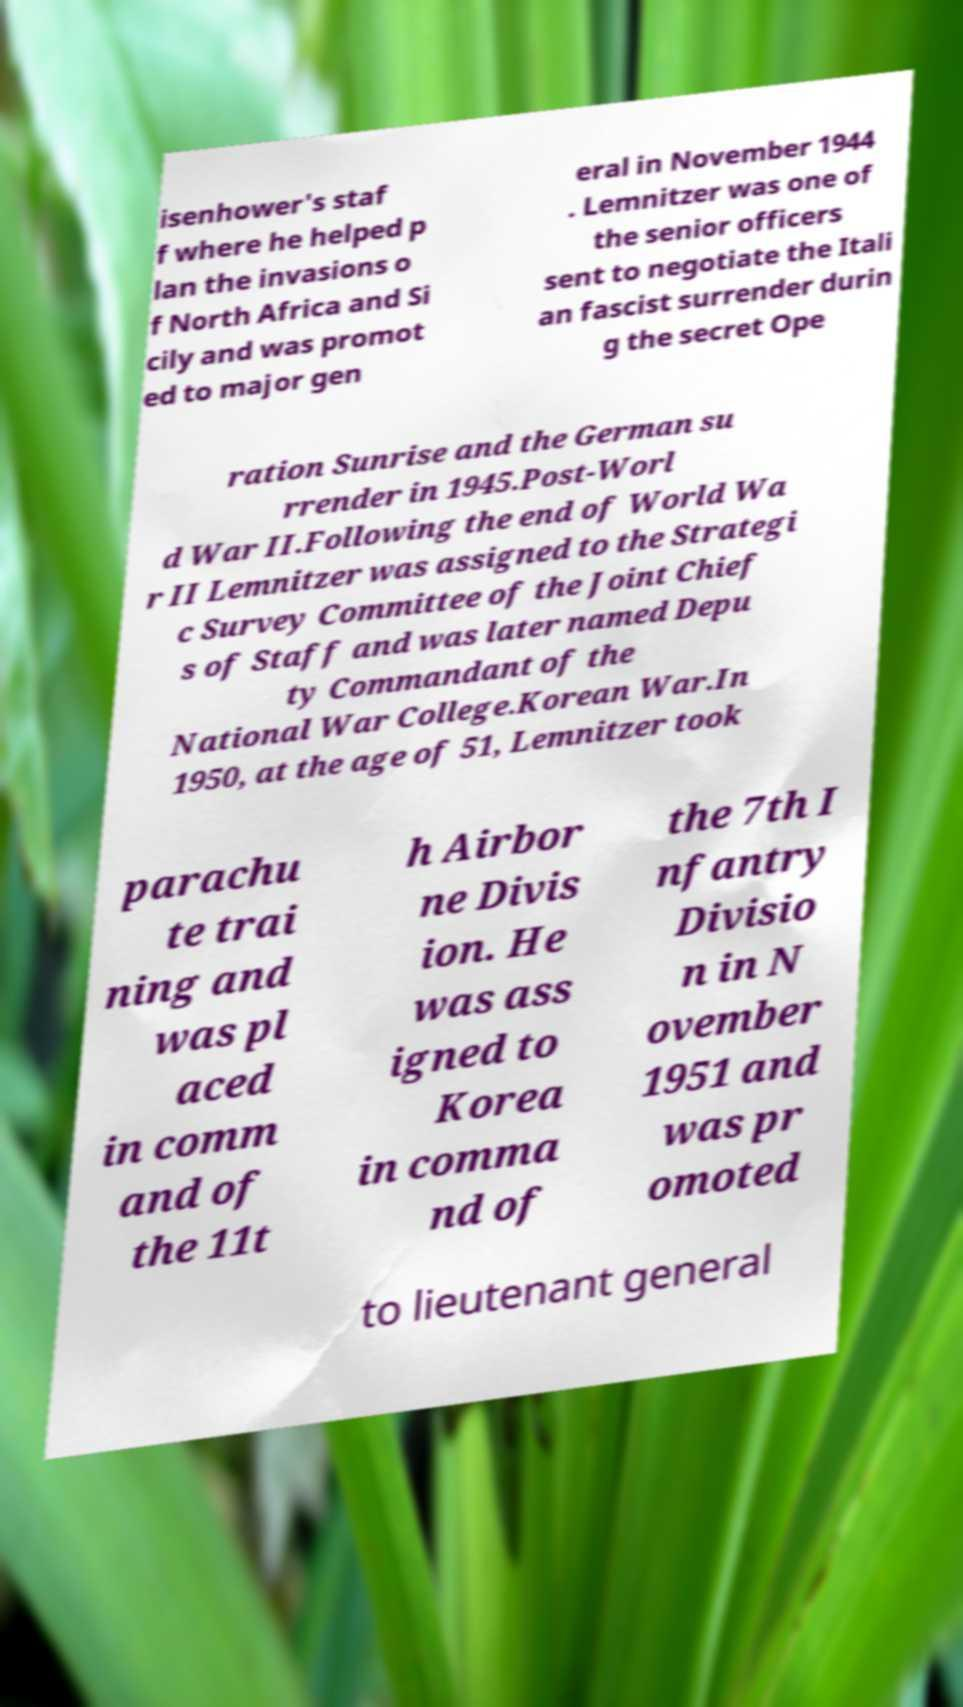Could you assist in decoding the text presented in this image and type it out clearly? isenhower's staf f where he helped p lan the invasions o f North Africa and Si cily and was promot ed to major gen eral in November 1944 . Lemnitzer was one of the senior officers sent to negotiate the Itali an fascist surrender durin g the secret Ope ration Sunrise and the German su rrender in 1945.Post-Worl d War II.Following the end of World Wa r II Lemnitzer was assigned to the Strategi c Survey Committee of the Joint Chief s of Staff and was later named Depu ty Commandant of the National War College.Korean War.In 1950, at the age of 51, Lemnitzer took parachu te trai ning and was pl aced in comm and of the 11t h Airbor ne Divis ion. He was ass igned to Korea in comma nd of the 7th I nfantry Divisio n in N ovember 1951 and was pr omoted to lieutenant general 